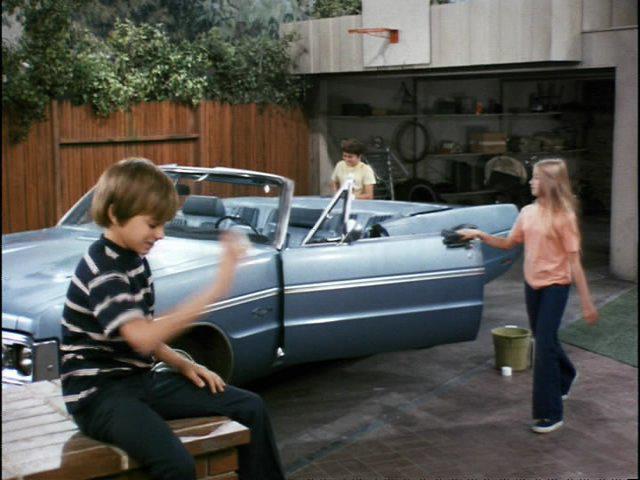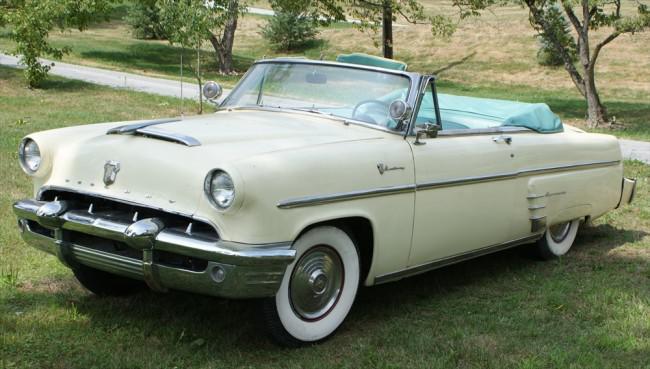The first image is the image on the left, the second image is the image on the right. Assess this claim about the two images: "An image shows a man sitting behind the wheel of a light blue convertible in front of an open garage.". Correct or not? Answer yes or no. No. The first image is the image on the left, the second image is the image on the right. Considering the images on both sides, is "No one is sitting in the car in the image on the left." valid? Answer yes or no. Yes. 